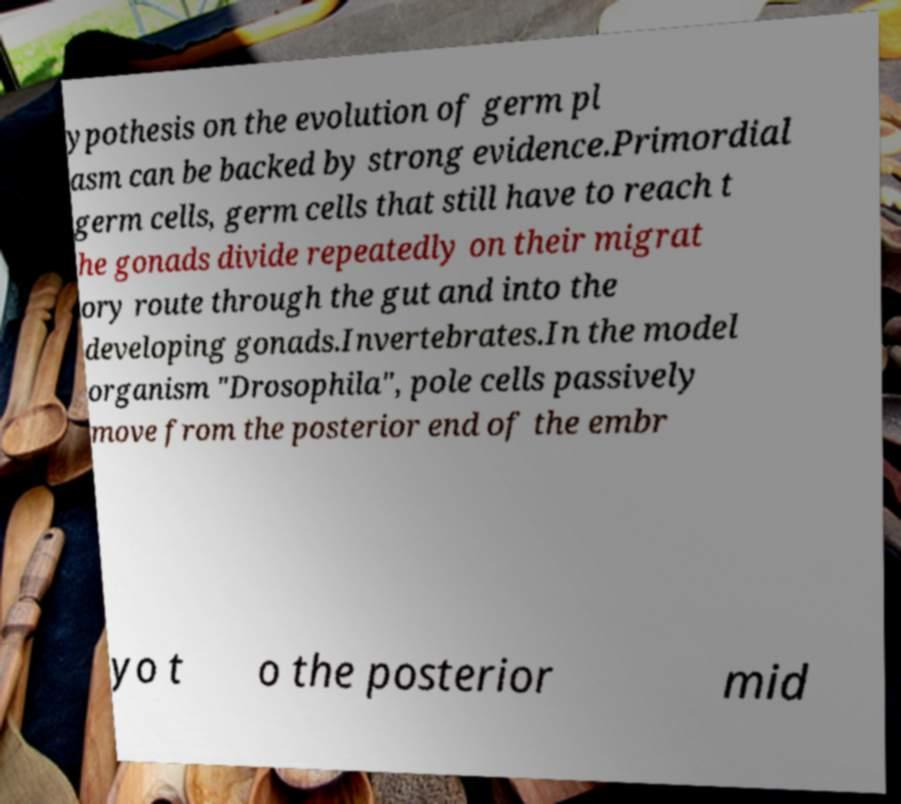Can you accurately transcribe the text from the provided image for me? ypothesis on the evolution of germ pl asm can be backed by strong evidence.Primordial germ cells, germ cells that still have to reach t he gonads divide repeatedly on their migrat ory route through the gut and into the developing gonads.Invertebrates.In the model organism "Drosophila", pole cells passively move from the posterior end of the embr yo t o the posterior mid 